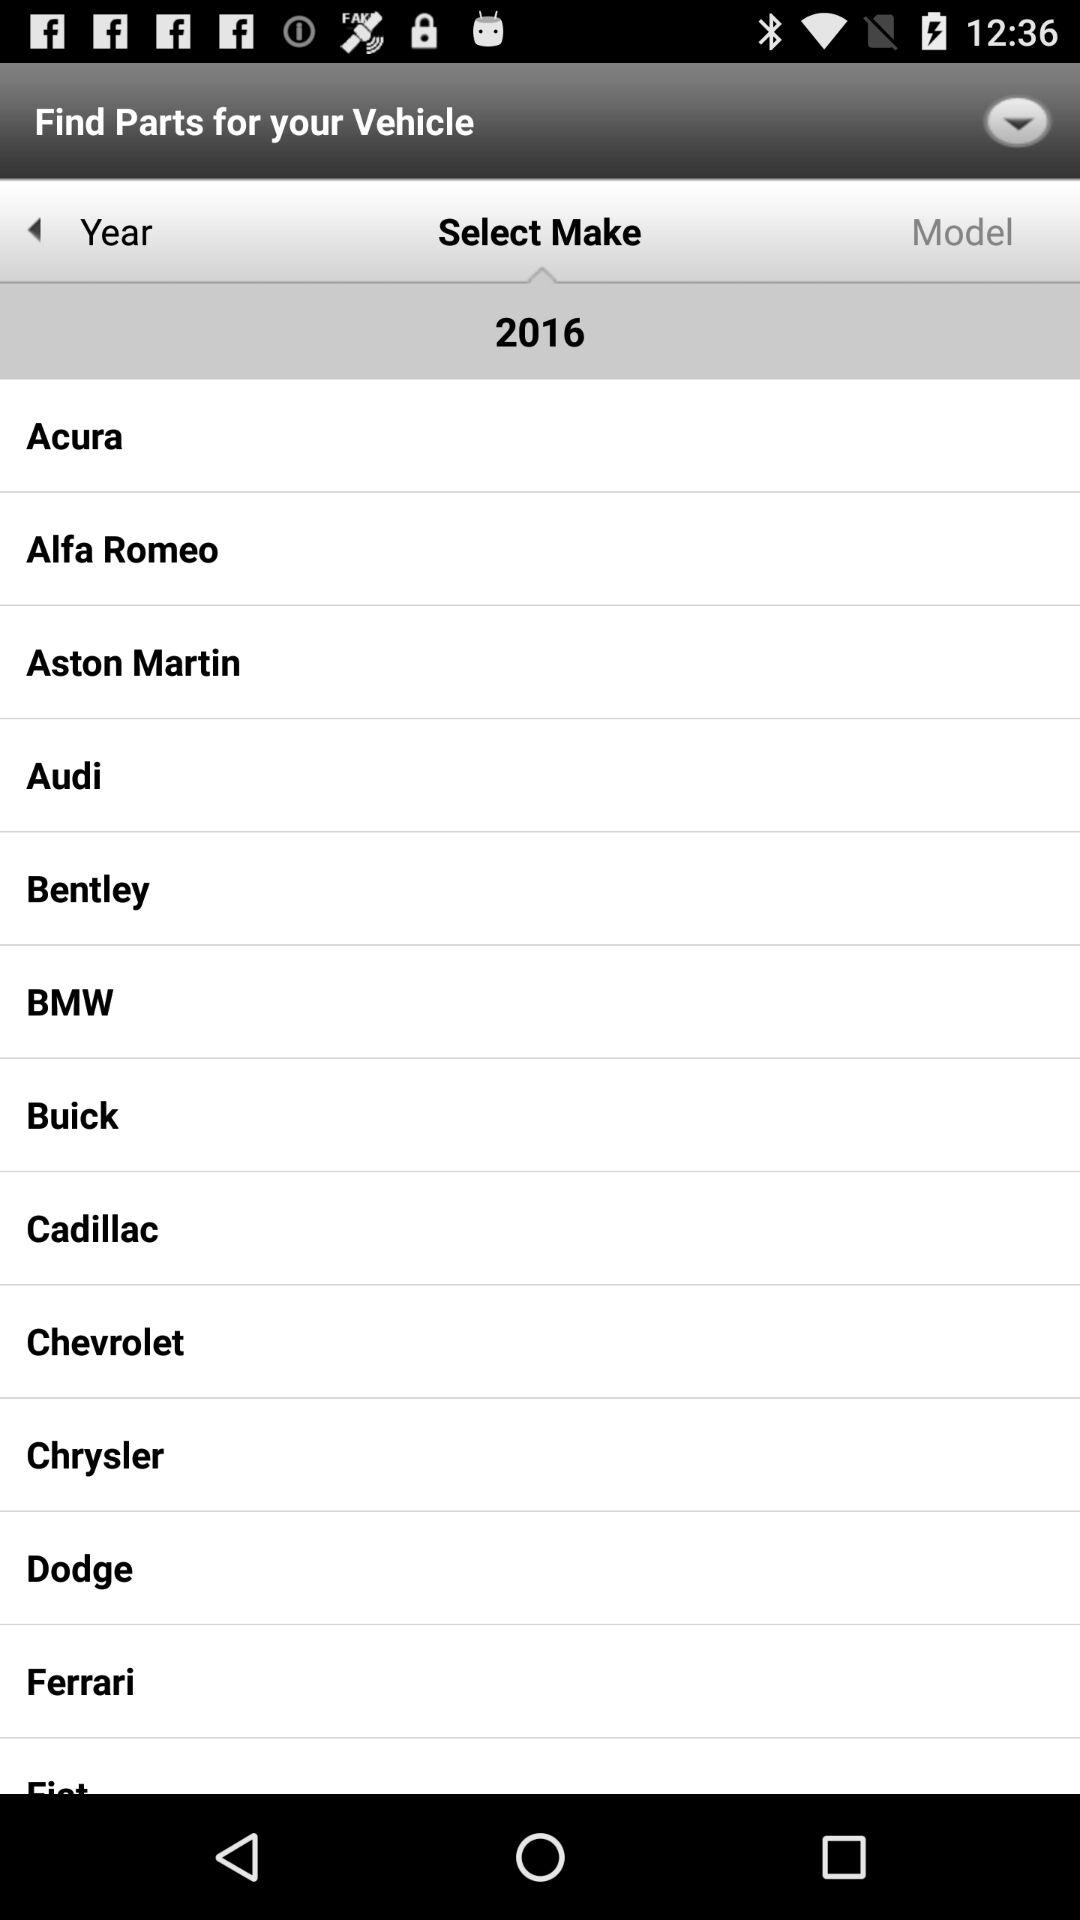What are the different available vehicle makers? The different available vehicle makers are "Acura", "Alfa Romeo", "Aston Martin", "Audi", "Bentley", "BMW", "Buick", "Cadillac", "Chevrolet", "Chrysler", "Dodge" and "Ferrari". 